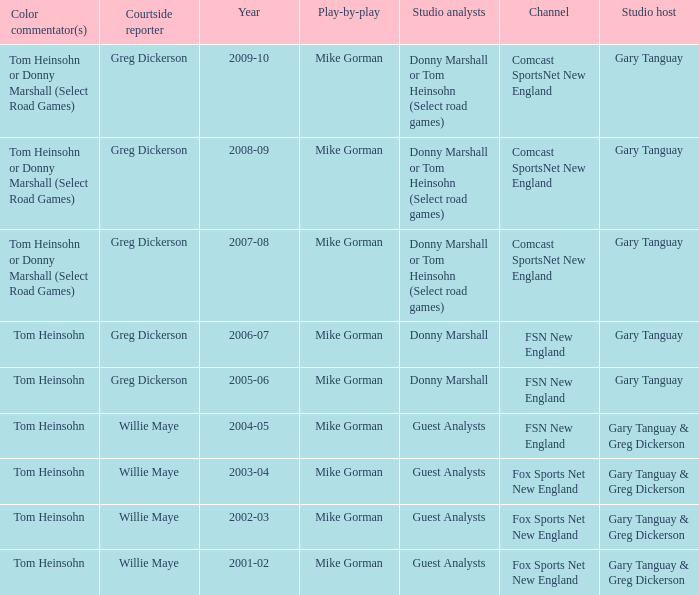Who is the courtside reporter for the year 2009-10? Greg Dickerson. 